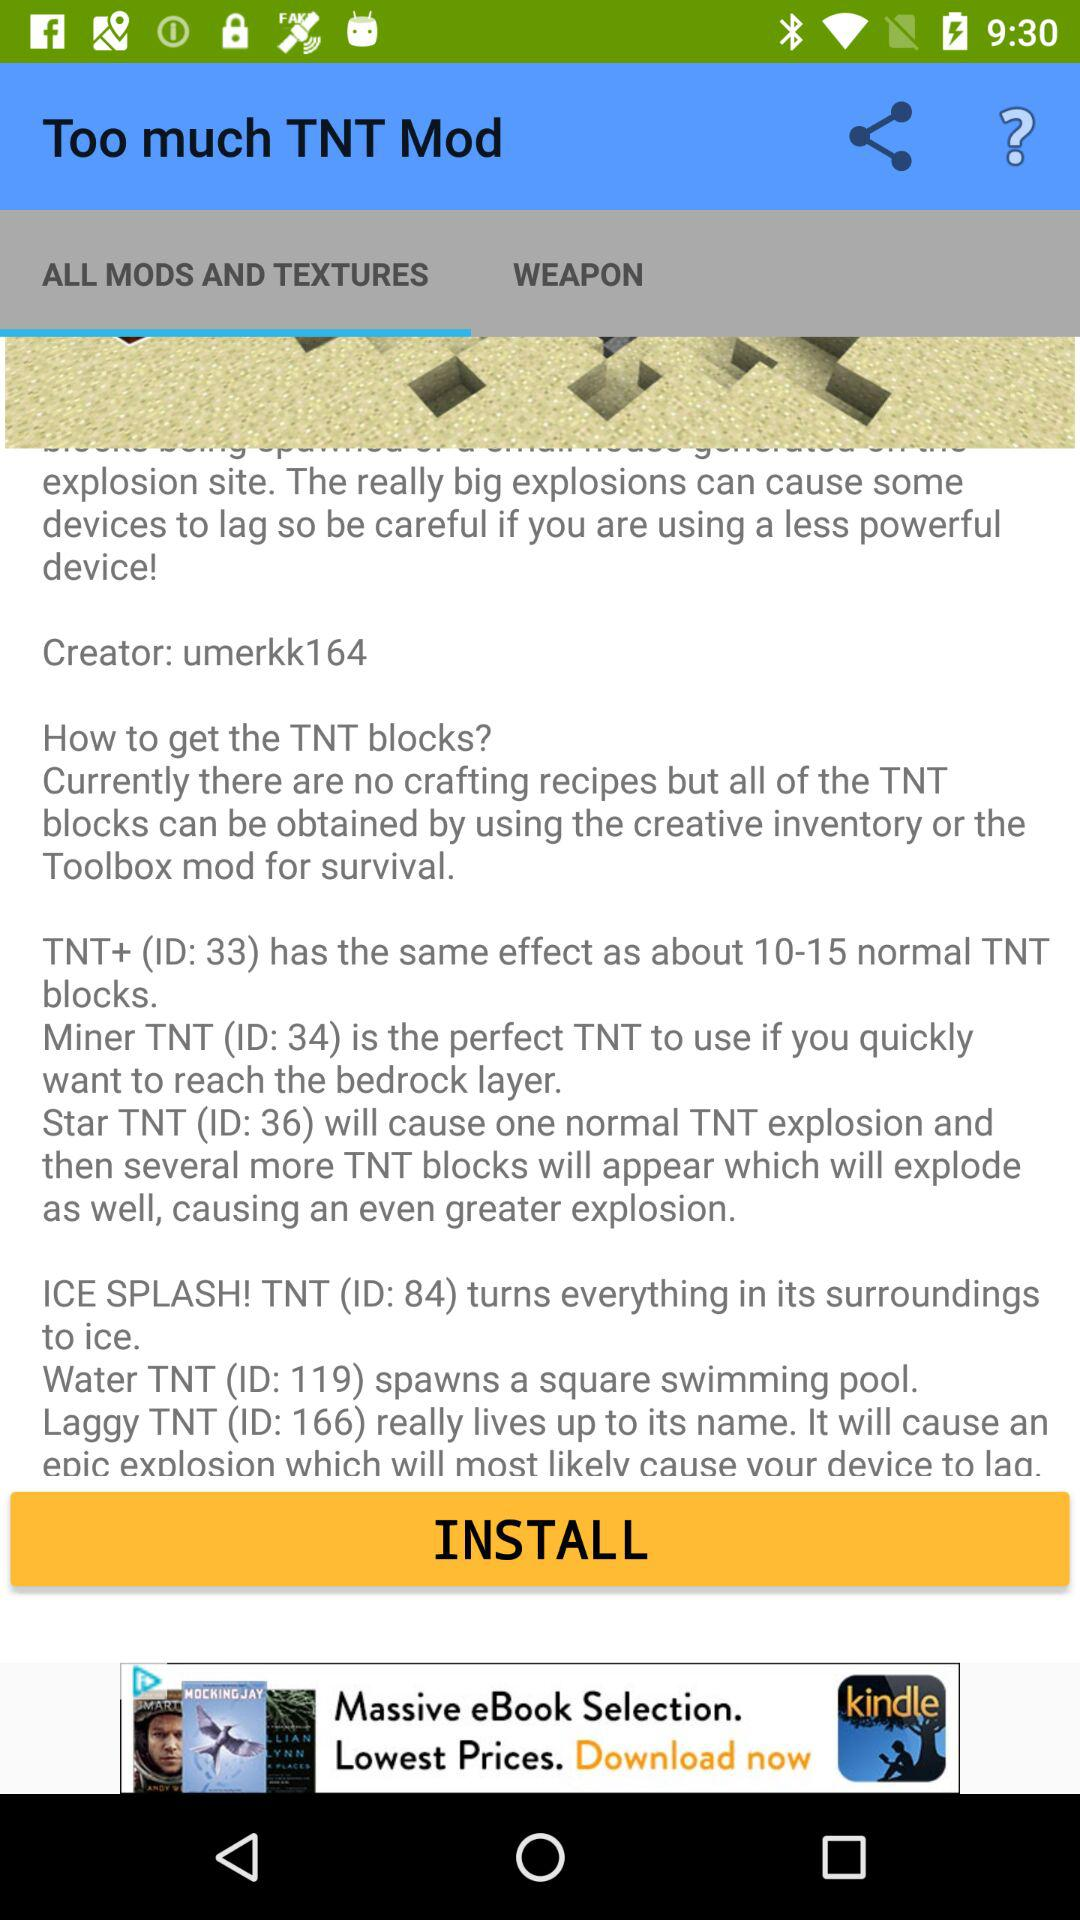How many TNT blocks are there in the mod?
Answer the question using a single word or phrase. 6 